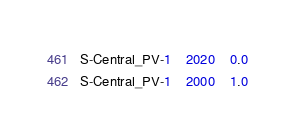<code> <loc_0><loc_0><loc_500><loc_500><_SQL_>S-Central_PV-1	2020	0.0
S-Central_PV-1	2000	1.0
</code> 